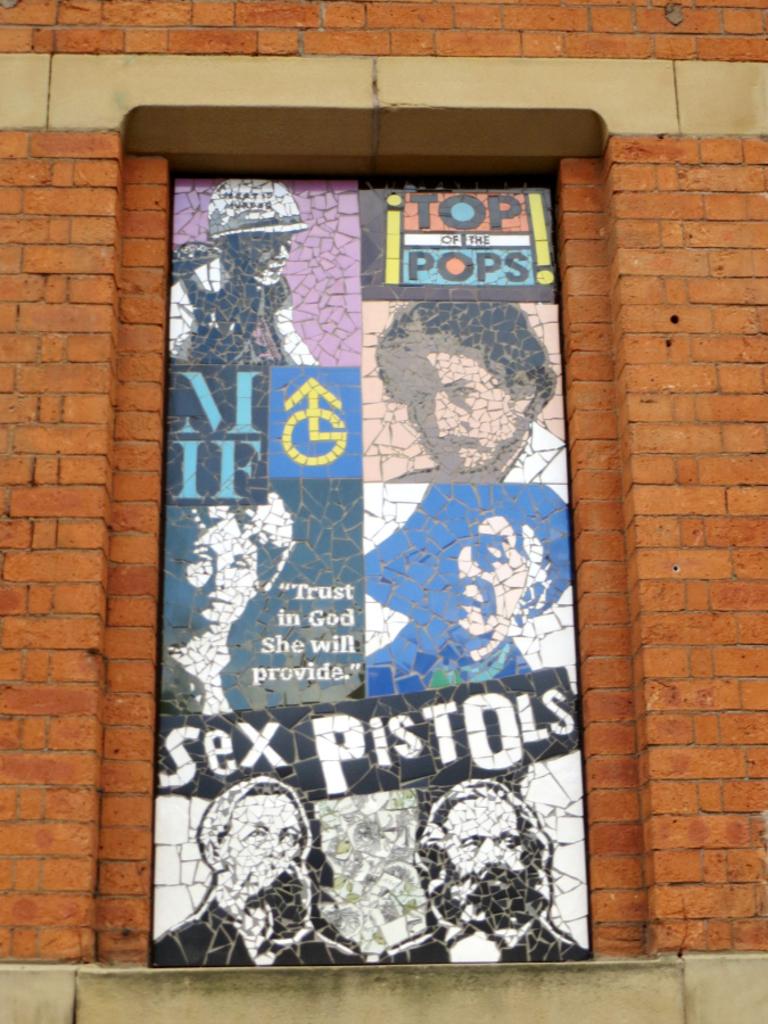What band is on the poster?
Offer a very short reply. Sex pistols. What band is featured at the bottom?
Give a very brief answer. Sex pistols. 